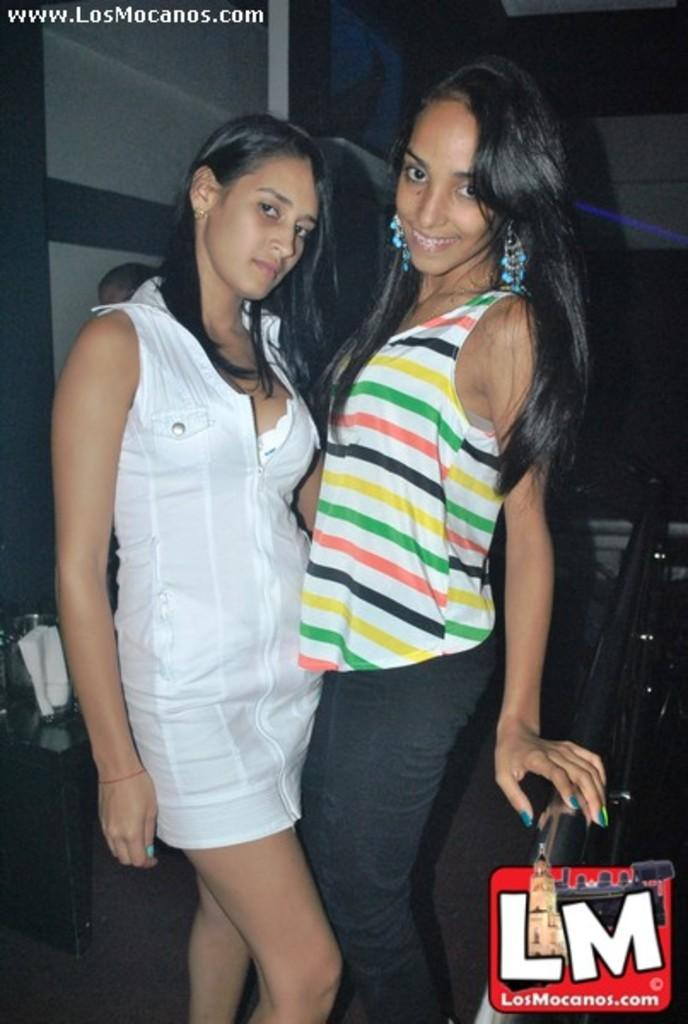How many people are in the image? There are two women in the image. What are the women doing in the image? The women are standing. What type of cats can be seen participating in the protest in the image? There are no cats or protest present in the image; it features two women standing. 